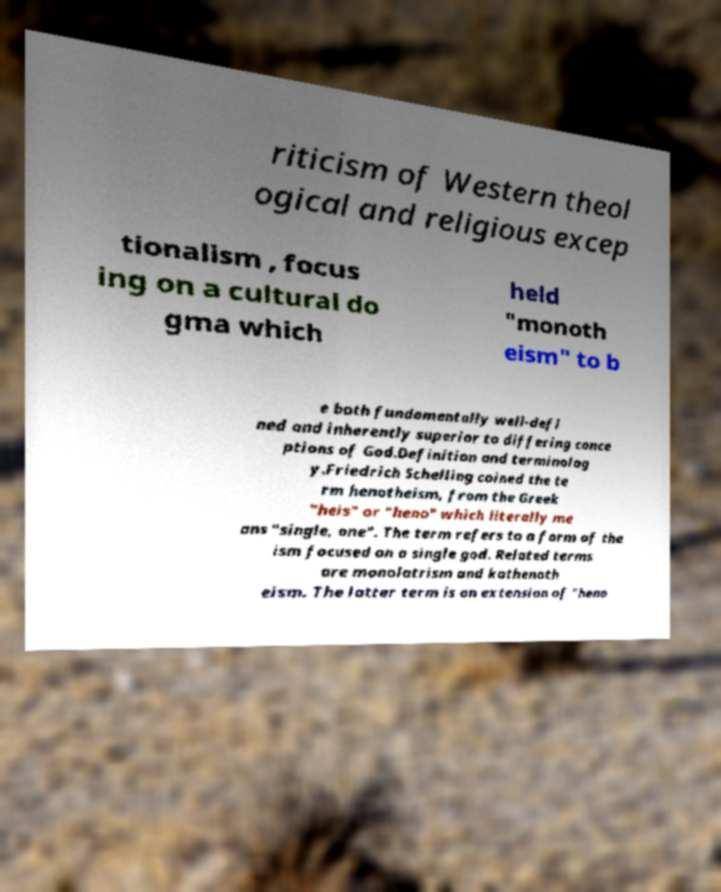There's text embedded in this image that I need extracted. Can you transcribe it verbatim? riticism of Western theol ogical and religious excep tionalism , focus ing on a cultural do gma which held "monoth eism" to b e both fundamentally well-defi ned and inherently superior to differing conce ptions of God.Definition and terminolog y.Friedrich Schelling coined the te rm henotheism, from the Greek "heis" or "heno" which literally me ans "single, one". The term refers to a form of the ism focused on a single god. Related terms are monolatrism and kathenoth eism. The latter term is an extension of "heno 